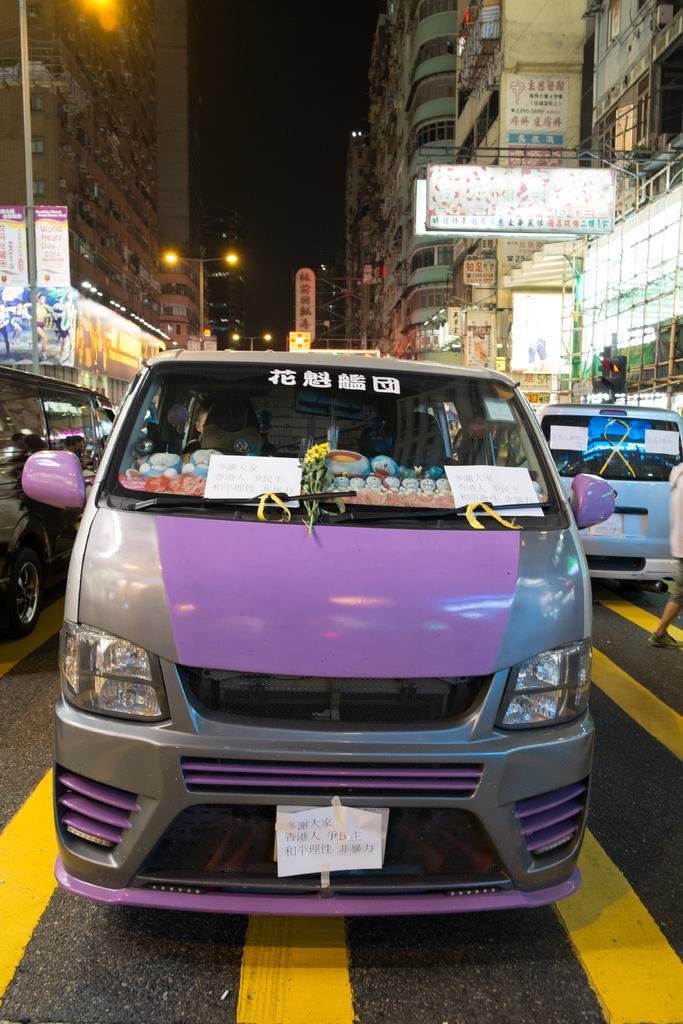Could you give a brief overview of what you see in this image? In this image we can see a van is on the road. To the both sides of the image vehicles are there and buildings are present with banners and lights. 